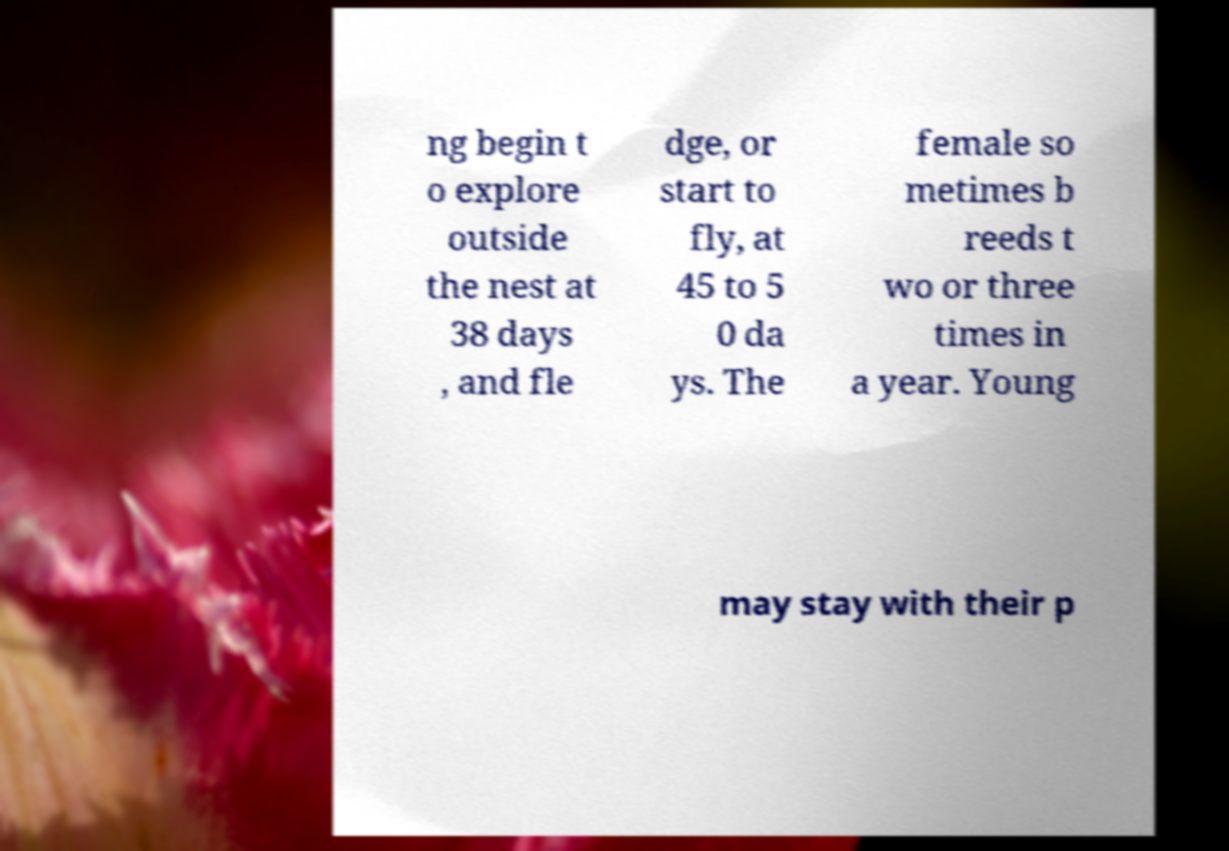What messages or text are displayed in this image? I need them in a readable, typed format. ng begin t o explore outside the nest at 38 days , and fle dge, or start to fly, at 45 to 5 0 da ys. The female so metimes b reeds t wo or three times in a year. Young may stay with their p 